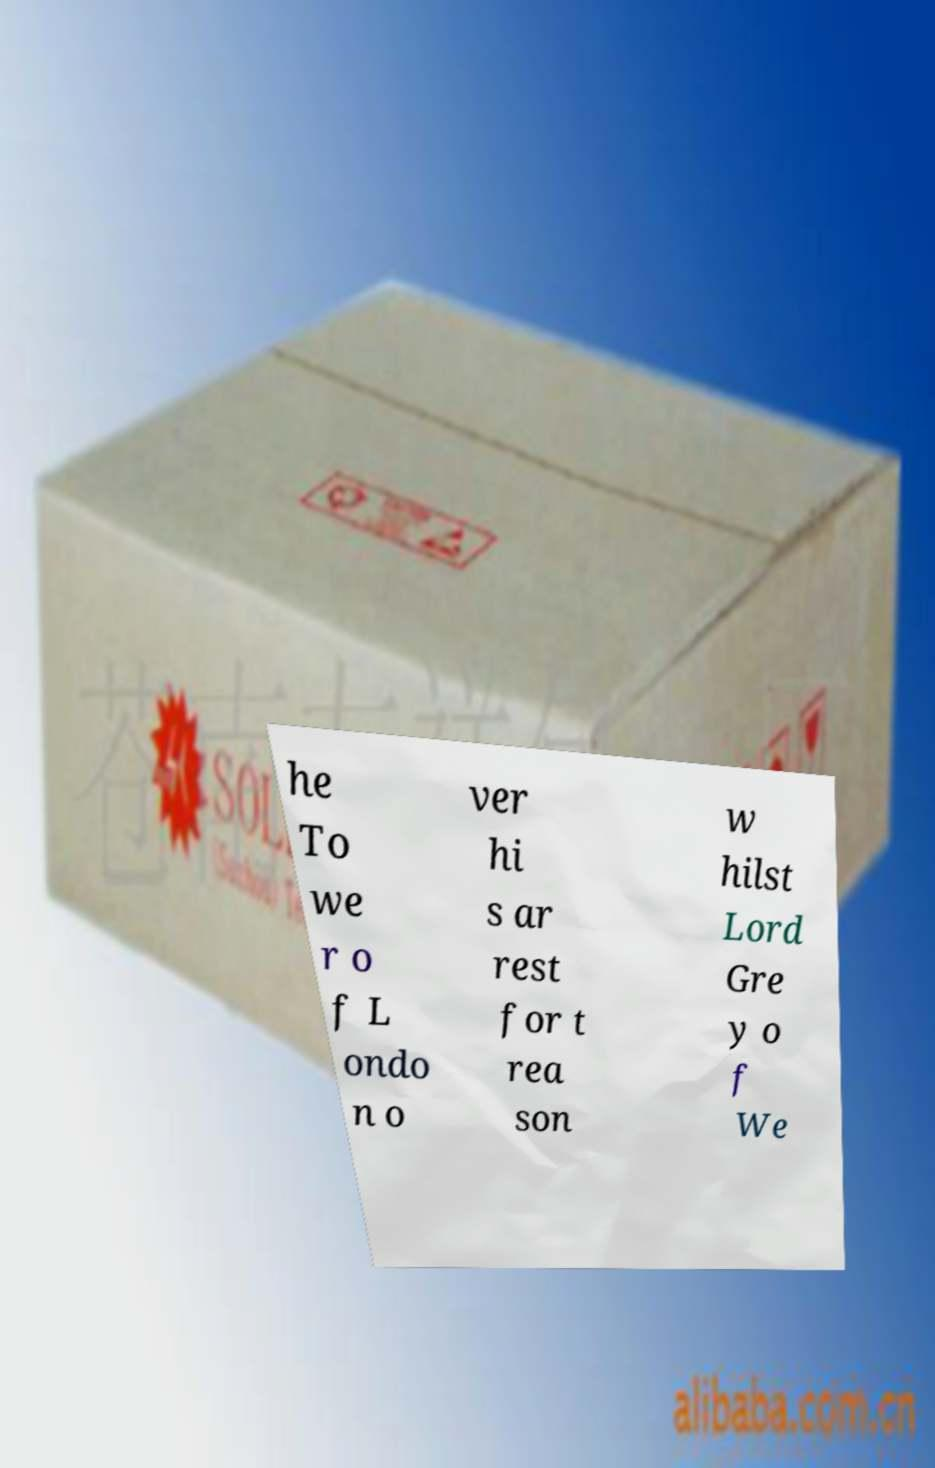Can you read and provide the text displayed in the image?This photo seems to have some interesting text. Can you extract and type it out for me? he To we r o f L ondo n o ver hi s ar rest for t rea son w hilst Lord Gre y o f We 